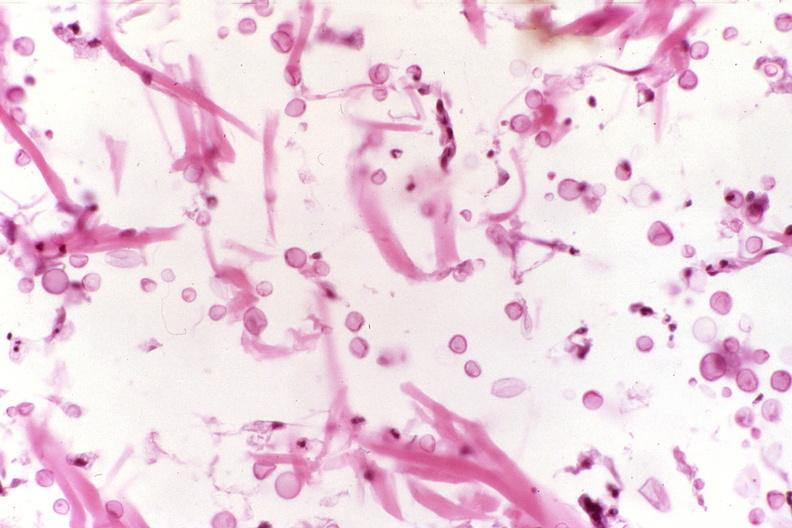does this image show cryptococcal dematitis?
Answer the question using a single word or phrase. Yes 